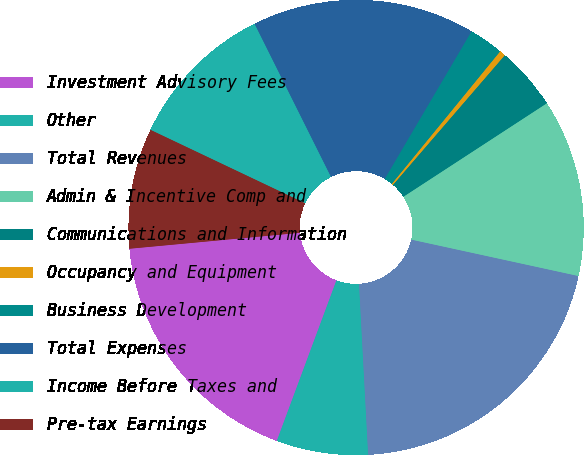Convert chart to OTSL. <chart><loc_0><loc_0><loc_500><loc_500><pie_chart><fcel>Investment Advisory Fees<fcel>Other<fcel>Total Revenues<fcel>Admin & Incentive Comp and<fcel>Communications and Information<fcel>Occupancy and Equipment<fcel>Business Development<fcel>Total Expenses<fcel>Income Before Taxes and<fcel>Pre-tax Earnings<nl><fcel>17.86%<fcel>6.51%<fcel>20.74%<fcel>12.61%<fcel>4.48%<fcel>0.42%<fcel>2.45%<fcel>15.83%<fcel>10.58%<fcel>8.54%<nl></chart> 